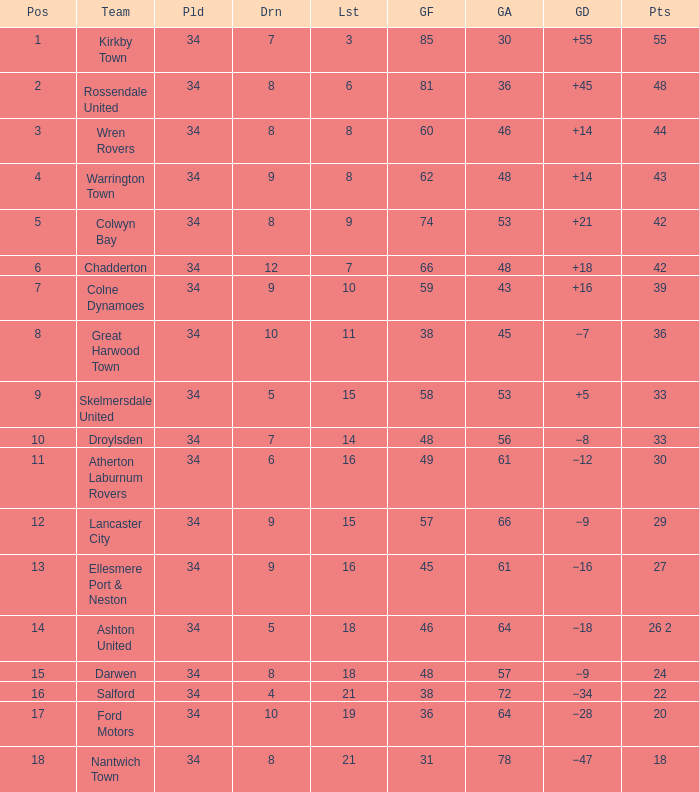What is the smallest number of goals against when 8 games were lost, and the goals for are 60? 46.0. 